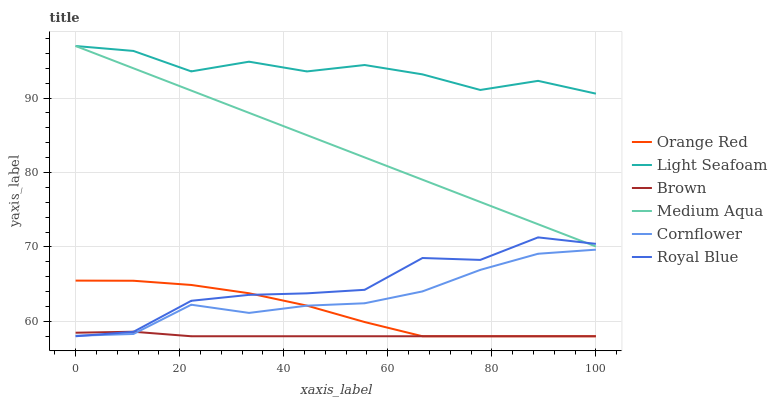Does Brown have the minimum area under the curve?
Answer yes or no. Yes. Does Light Seafoam have the maximum area under the curve?
Answer yes or no. Yes. Does Cornflower have the minimum area under the curve?
Answer yes or no. No. Does Cornflower have the maximum area under the curve?
Answer yes or no. No. Is Medium Aqua the smoothest?
Answer yes or no. Yes. Is Royal Blue the roughest?
Answer yes or no. Yes. Is Cornflower the smoothest?
Answer yes or no. No. Is Cornflower the roughest?
Answer yes or no. No. Does Brown have the lowest value?
Answer yes or no. Yes. Does Cornflower have the lowest value?
Answer yes or no. No. Does Light Seafoam have the highest value?
Answer yes or no. Yes. Does Cornflower have the highest value?
Answer yes or no. No. Is Brown less than Medium Aqua?
Answer yes or no. Yes. Is Light Seafoam greater than Orange Red?
Answer yes or no. Yes. Does Brown intersect Orange Red?
Answer yes or no. Yes. Is Brown less than Orange Red?
Answer yes or no. No. Is Brown greater than Orange Red?
Answer yes or no. No. Does Brown intersect Medium Aqua?
Answer yes or no. No. 